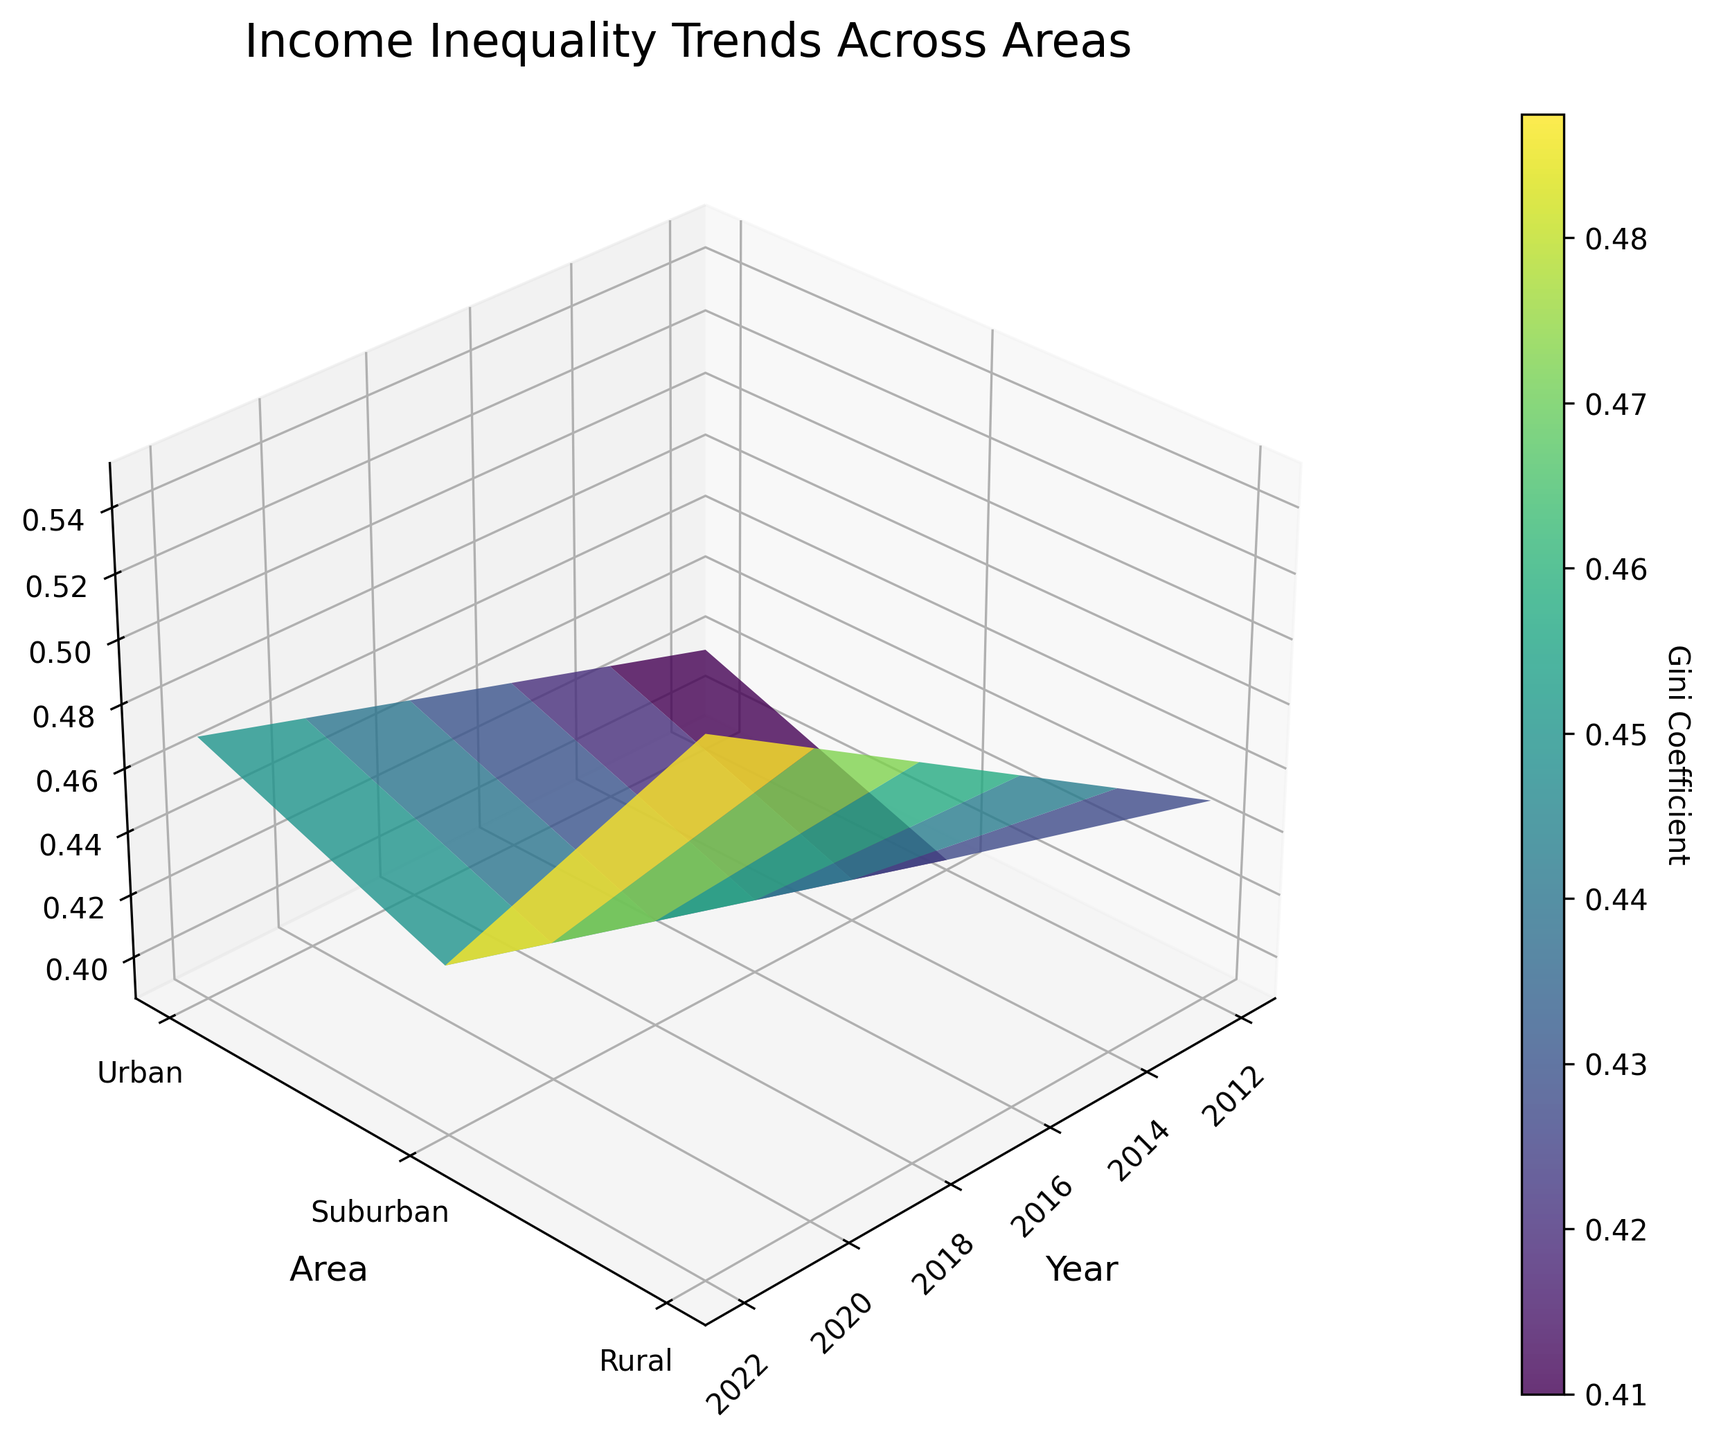What is the title of the 3D surface plot? The title of the plot is found at the top and it summarizes the entire figure. It states "Income Inequality Trends Across Areas".
Answer: Income Inequality Trends Across Areas What are the labels on the X, Y, and Z axes? The labels on the axes describe what each axis represents. The X axis is labeled "Year", the Y axis is labeled "Area", and the Z axis is labeled "Income Inequality (Gini)".
Answer: Year, Area, Income Inequality (Gini) Which area had the highest income inequality Gini coefficient in 2022? To determine this, look at the Z value for the year 2022 across different areas. The highest Gini coefficient is observed for the Urban area, which is 0.55.
Answer: Urban How did the income inequality in suburban areas change from 2014 to 2022? Compare the Z values (Gini coefficient) for the suburban area between the years 2014 and 2022. In 2014, it was 0.40; in 2022, it increased to 0.44.
Answer: Increased by 0.04 Which area showed the smallest change in income inequality over the decade? To answer this, observe the range of Z values for each area from 2012 to 2022. The Suburban area's Gini coefficient ranged from 0.39 to 0.44, which indicates the smallest change (0.05).
Answer: Suburban In 2016, which area had the median income inequality rate? To determine this, compare the Z values for the year 2016 across all areas. The Gini coefficients are Urban 0.49, Suburban 0.41, and Rural 0.44. The median value is 0.44 for the Rural area.
Answer: Rural How did income inequality in urban areas evolve from 2012 to 2022? To determine the evolution, observe the Z values for the Urban area across the years. There was a consistent increase: 0.45 in 2012, 0.47 in 2014, 0.49 in 2016, 0.51 in 2018, 0.53 in 2020, and 0.55 in 2022.
Answer: Consistently increased What is the surface color gradient indicating in the plot? The surface color gradient represents the variation in the Gini coefficient values. The gradient from lighter to darker shades indicates increasing income inequality.
Answer: Variation in Gini coefficient By what percentage did the Gini coefficient change in rural areas from 2012 to 2022? First, calculate the Gini coefficient change: 0.47 - 0.42 = 0.05. Then find the percentage change: (0.05/0.42) * 100 ≈ 11.90%.
Answer: Approx. 11.90% Which year had the highest average income inequality across all areas? Calculate the average Gini coefficient for each year. For 2022: (0.55 + 0.44 + 0.47) / 3 = 0.4867. 2022 has the highest average (followed by 2020).
Answer: 2022 